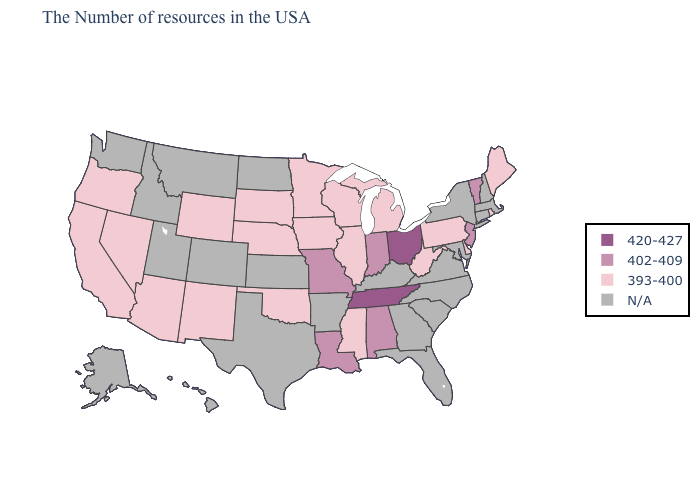Does South Dakota have the lowest value in the USA?
Be succinct. Yes. What is the value of Delaware?
Quick response, please. 393-400. Among the states that border Texas , which have the lowest value?
Keep it brief. Oklahoma, New Mexico. What is the lowest value in states that border Minnesota?
Be succinct. 393-400. What is the value of Pennsylvania?
Write a very short answer. 393-400. What is the value of Florida?
Short answer required. N/A. What is the value of Delaware?
Quick response, please. 393-400. Name the states that have a value in the range 420-427?
Concise answer only. Ohio, Tennessee. What is the highest value in states that border Pennsylvania?
Short answer required. 420-427. Name the states that have a value in the range N/A?
Keep it brief. Massachusetts, New Hampshire, Connecticut, New York, Maryland, Virginia, North Carolina, South Carolina, Florida, Georgia, Kentucky, Arkansas, Kansas, Texas, North Dakota, Colorado, Utah, Montana, Idaho, Washington, Alaska, Hawaii. Name the states that have a value in the range N/A?
Answer briefly. Massachusetts, New Hampshire, Connecticut, New York, Maryland, Virginia, North Carolina, South Carolina, Florida, Georgia, Kentucky, Arkansas, Kansas, Texas, North Dakota, Colorado, Utah, Montana, Idaho, Washington, Alaska, Hawaii. Does Ohio have the highest value in the MidWest?
Answer briefly. Yes. 